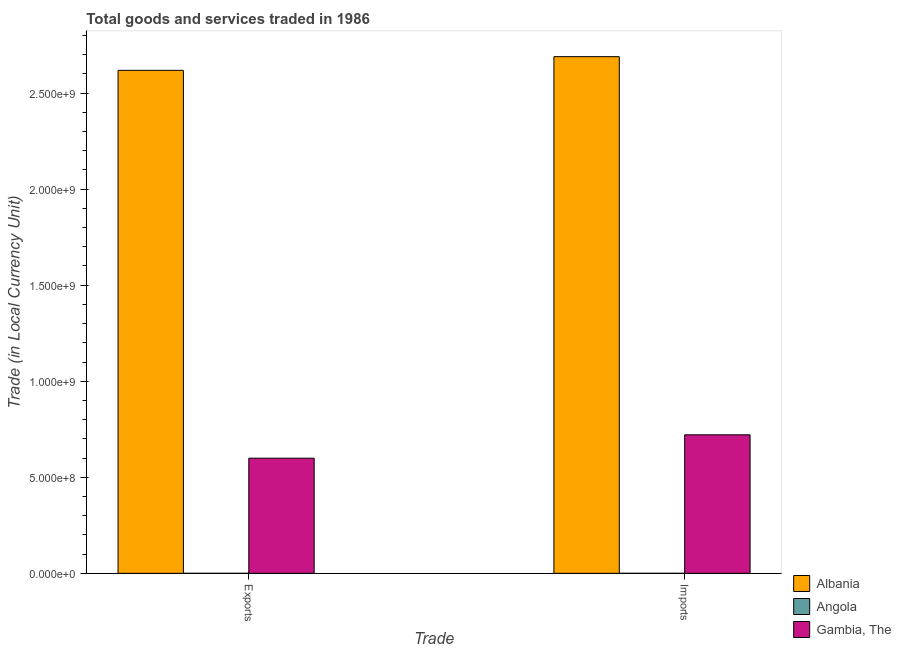Are the number of bars per tick equal to the number of legend labels?
Offer a very short reply. Yes. What is the label of the 1st group of bars from the left?
Offer a very short reply. Exports. What is the export of goods and services in Albania?
Ensure brevity in your answer.  2.62e+09. Across all countries, what is the maximum export of goods and services?
Give a very brief answer. 2.62e+09. Across all countries, what is the minimum export of goods and services?
Keep it short and to the point. 100. In which country was the imports of goods and services maximum?
Your answer should be compact. Albania. In which country was the imports of goods and services minimum?
Offer a very short reply. Angola. What is the total imports of goods and services in the graph?
Your answer should be compact. 3.41e+09. What is the difference between the export of goods and services in Angola and that in Albania?
Offer a terse response. -2.62e+09. What is the difference between the imports of goods and services in Gambia, The and the export of goods and services in Albania?
Provide a short and direct response. -1.90e+09. What is the average export of goods and services per country?
Offer a terse response. 1.07e+09. In how many countries, is the imports of goods and services greater than 900000000 LCU?
Your response must be concise. 1. What is the ratio of the export of goods and services in Albania to that in Angola?
Offer a terse response. 2.62e+07. Is the export of goods and services in Albania less than that in Gambia, The?
Your answer should be very brief. No. In how many countries, is the export of goods and services greater than the average export of goods and services taken over all countries?
Your response must be concise. 1. What does the 3rd bar from the left in Exports represents?
Provide a succinct answer. Gambia, The. What does the 3rd bar from the right in Imports represents?
Your answer should be very brief. Albania. Are all the bars in the graph horizontal?
Offer a terse response. No. How many countries are there in the graph?
Make the answer very short. 3. Does the graph contain any zero values?
Make the answer very short. No. Does the graph contain grids?
Your answer should be very brief. No. How many legend labels are there?
Offer a very short reply. 3. What is the title of the graph?
Your response must be concise. Total goods and services traded in 1986. What is the label or title of the X-axis?
Provide a succinct answer. Trade. What is the label or title of the Y-axis?
Your response must be concise. Trade (in Local Currency Unit). What is the Trade (in Local Currency Unit) of Albania in Exports?
Your answer should be very brief. 2.62e+09. What is the Trade (in Local Currency Unit) of Angola in Exports?
Provide a short and direct response. 100. What is the Trade (in Local Currency Unit) of Gambia, The in Exports?
Provide a short and direct response. 5.99e+08. What is the Trade (in Local Currency Unit) of Albania in Imports?
Your answer should be very brief. 2.69e+09. What is the Trade (in Local Currency Unit) of Gambia, The in Imports?
Offer a very short reply. 7.21e+08. Across all Trade, what is the maximum Trade (in Local Currency Unit) in Albania?
Offer a terse response. 2.69e+09. Across all Trade, what is the maximum Trade (in Local Currency Unit) in Gambia, The?
Offer a terse response. 7.21e+08. Across all Trade, what is the minimum Trade (in Local Currency Unit) of Albania?
Give a very brief answer. 2.62e+09. Across all Trade, what is the minimum Trade (in Local Currency Unit) in Angola?
Offer a terse response. 100. Across all Trade, what is the minimum Trade (in Local Currency Unit) of Gambia, The?
Your response must be concise. 5.99e+08. What is the total Trade (in Local Currency Unit) in Albania in the graph?
Provide a succinct answer. 5.31e+09. What is the total Trade (in Local Currency Unit) in Gambia, The in the graph?
Make the answer very short. 1.32e+09. What is the difference between the Trade (in Local Currency Unit) of Albania in Exports and that in Imports?
Make the answer very short. -7.13e+07. What is the difference between the Trade (in Local Currency Unit) in Gambia, The in Exports and that in Imports?
Offer a very short reply. -1.22e+08. What is the difference between the Trade (in Local Currency Unit) in Albania in Exports and the Trade (in Local Currency Unit) in Angola in Imports?
Provide a short and direct response. 2.62e+09. What is the difference between the Trade (in Local Currency Unit) in Albania in Exports and the Trade (in Local Currency Unit) in Gambia, The in Imports?
Give a very brief answer. 1.90e+09. What is the difference between the Trade (in Local Currency Unit) in Angola in Exports and the Trade (in Local Currency Unit) in Gambia, The in Imports?
Your response must be concise. -7.21e+08. What is the average Trade (in Local Currency Unit) in Albania per Trade?
Your answer should be very brief. 2.65e+09. What is the average Trade (in Local Currency Unit) of Angola per Trade?
Offer a very short reply. 100. What is the average Trade (in Local Currency Unit) in Gambia, The per Trade?
Offer a very short reply. 6.60e+08. What is the difference between the Trade (in Local Currency Unit) in Albania and Trade (in Local Currency Unit) in Angola in Exports?
Provide a short and direct response. 2.62e+09. What is the difference between the Trade (in Local Currency Unit) of Albania and Trade (in Local Currency Unit) of Gambia, The in Exports?
Offer a terse response. 2.02e+09. What is the difference between the Trade (in Local Currency Unit) in Angola and Trade (in Local Currency Unit) in Gambia, The in Exports?
Provide a short and direct response. -5.99e+08. What is the difference between the Trade (in Local Currency Unit) of Albania and Trade (in Local Currency Unit) of Angola in Imports?
Your answer should be very brief. 2.69e+09. What is the difference between the Trade (in Local Currency Unit) of Albania and Trade (in Local Currency Unit) of Gambia, The in Imports?
Keep it short and to the point. 1.97e+09. What is the difference between the Trade (in Local Currency Unit) in Angola and Trade (in Local Currency Unit) in Gambia, The in Imports?
Your answer should be very brief. -7.21e+08. What is the ratio of the Trade (in Local Currency Unit) of Albania in Exports to that in Imports?
Keep it short and to the point. 0.97. What is the ratio of the Trade (in Local Currency Unit) of Gambia, The in Exports to that in Imports?
Offer a very short reply. 0.83. What is the difference between the highest and the second highest Trade (in Local Currency Unit) of Albania?
Ensure brevity in your answer.  7.13e+07. What is the difference between the highest and the second highest Trade (in Local Currency Unit) of Angola?
Offer a very short reply. 0. What is the difference between the highest and the second highest Trade (in Local Currency Unit) in Gambia, The?
Make the answer very short. 1.22e+08. What is the difference between the highest and the lowest Trade (in Local Currency Unit) of Albania?
Offer a very short reply. 7.13e+07. What is the difference between the highest and the lowest Trade (in Local Currency Unit) of Angola?
Offer a terse response. 0. What is the difference between the highest and the lowest Trade (in Local Currency Unit) in Gambia, The?
Give a very brief answer. 1.22e+08. 